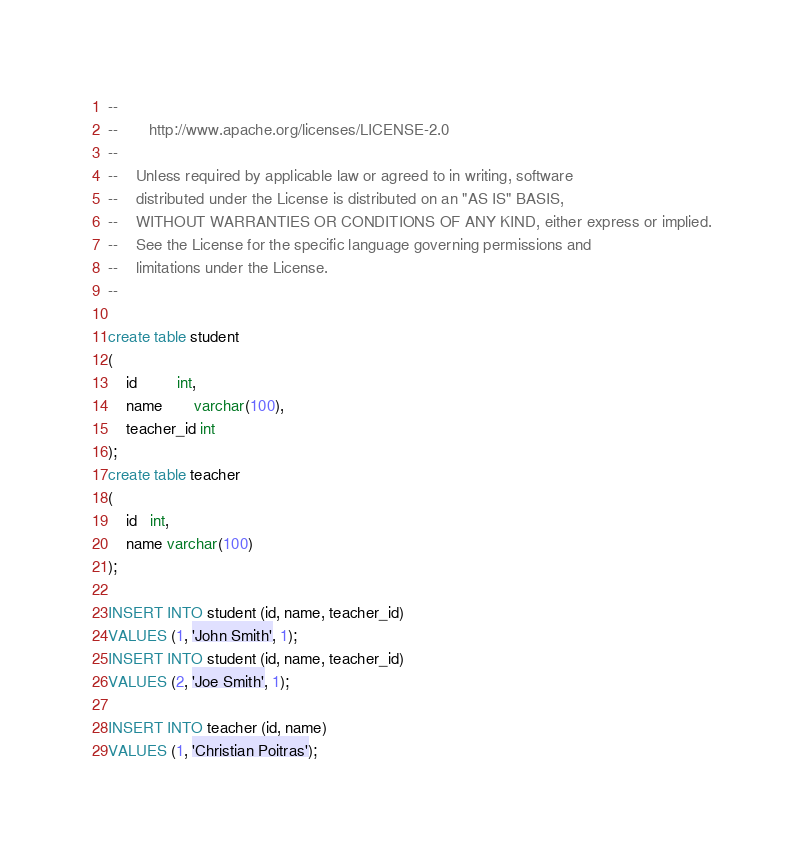<code> <loc_0><loc_0><loc_500><loc_500><_SQL_>--
--       http://www.apache.org/licenses/LICENSE-2.0
--
--    Unless required by applicable law or agreed to in writing, software
--    distributed under the License is distributed on an "AS IS" BASIS,
--    WITHOUT WARRANTIES OR CONDITIONS OF ANY KIND, either express or implied.
--    See the License for the specific language governing permissions and
--    limitations under the License.
--

create table student
(
    id         int,
    name       varchar(100),
    teacher_id int
);
create table teacher
(
    id   int,
    name varchar(100)
);

INSERT INTO student (id, name, teacher_id)
VALUES (1, 'John Smith', 1);
INSERT INTO student (id, name, teacher_id)
VALUES (2, 'Joe Smith', 1);

INSERT INTO teacher (id, name)
VALUES (1, 'Christian Poitras');
</code> 